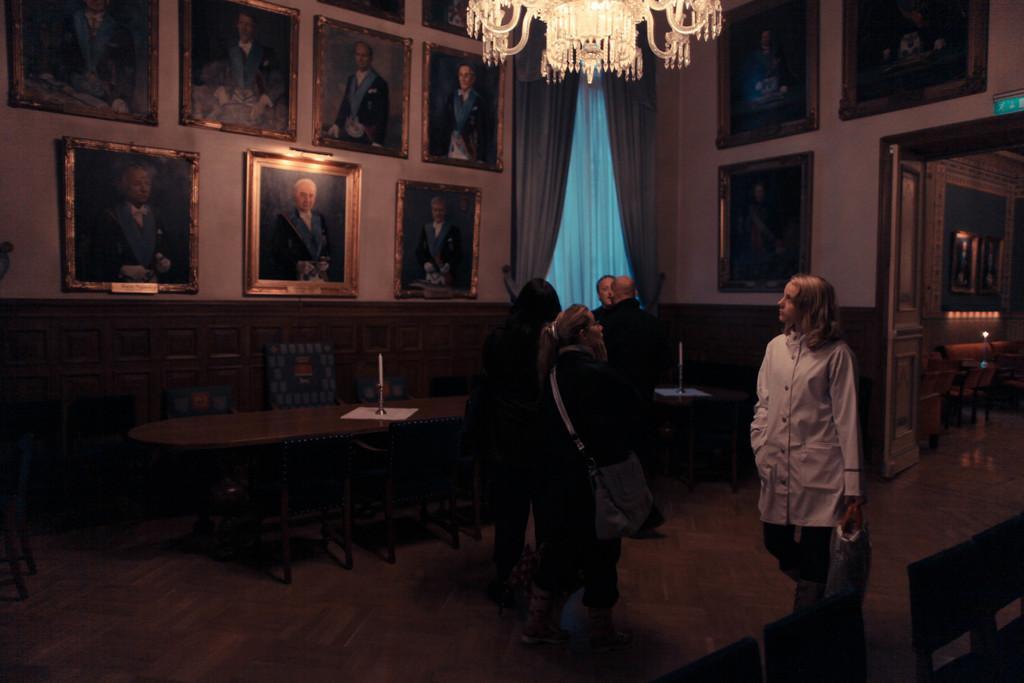Describe this image in one or two sentences. A girl with white dress walking on the floor beside two women of which one held a backpack and another woman looking at the wall which is full of photos. behind that there is curtain and above there is chandelier. On the left side two men were talking with each other. There is entrance door to enter this room. 